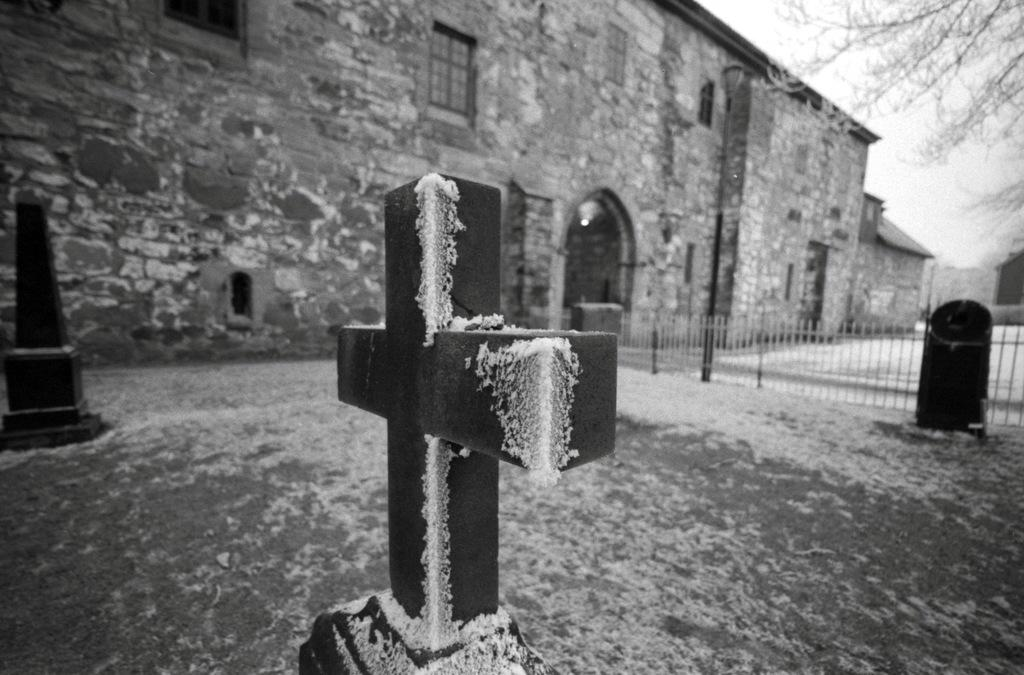What type of structure is present in the image? There is a building in the image. What is located in front of the building? There are cemeteries in front of the building. What is the weather like in the image? There is snow visible in the image, indicating a cold or wintry condition. What can be seen in the top right of the image? The sky and a tree are visible in the top right of the image. What type of butter is being used to maintain the condition of the tree in the image? There is no butter present in the image, and the condition of the tree is not mentioned. 